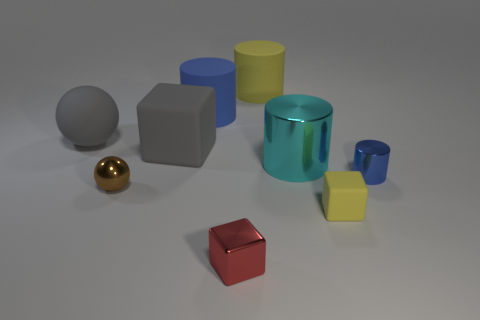Do the large sphere and the large cube have the same color?
Your response must be concise. Yes. What size is the yellow rubber thing in front of the blue metallic object?
Give a very brief answer. Small. There is a yellow thing that is in front of the matte cylinder that is to the right of the big blue thing; how big is it?
Your response must be concise. Small. There is a large yellow matte object; are there any metallic objects left of it?
Make the answer very short. Yes. Is the material of the large cylinder right of the big yellow matte thing the same as the tiny block on the right side of the large yellow matte cylinder?
Your response must be concise. No. Is the number of cylinders right of the tiny yellow object less than the number of large shiny things?
Keep it short and to the point. No. There is a object behind the large blue cylinder; what color is it?
Provide a succinct answer. Yellow. What is the tiny red cube that is in front of the shiny cylinder that is on the right side of the cyan cylinder made of?
Make the answer very short. Metal. Is there a yellow rubber object that has the same size as the red shiny thing?
Your answer should be very brief. Yes. What number of things are yellow things that are in front of the big cyan metal cylinder or blue objects that are on the right side of the tiny red object?
Offer a terse response. 2. 